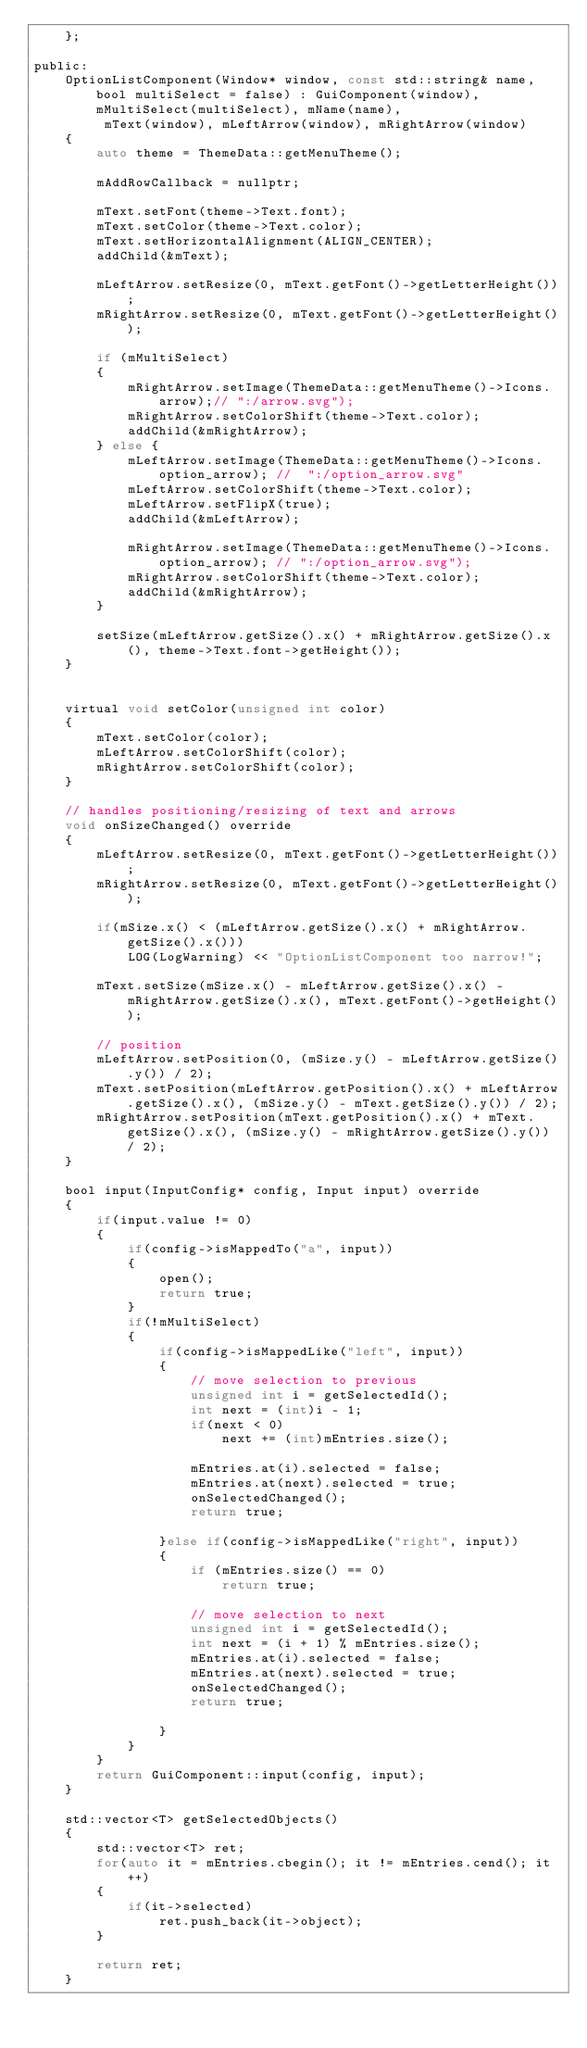Convert code to text. <code><loc_0><loc_0><loc_500><loc_500><_C_>	};

public:
	OptionListComponent(Window* window, const std::string& name, bool multiSelect = false) : GuiComponent(window), mMultiSelect(multiSelect), mName(name),
		 mText(window), mLeftArrow(window), mRightArrow(window)
	{
		auto theme = ThemeData::getMenuTheme();
		
		mAddRowCallback = nullptr;

		mText.setFont(theme->Text.font);
		mText.setColor(theme->Text.color);
		mText.setHorizontalAlignment(ALIGN_CENTER);
		addChild(&mText);

		mLeftArrow.setResize(0, mText.getFont()->getLetterHeight());
		mRightArrow.setResize(0, mText.getFont()->getLetterHeight());

		if (mMultiSelect)
		{
			mRightArrow.setImage(ThemeData::getMenuTheme()->Icons.arrow);// ":/arrow.svg");
			mRightArrow.setColorShift(theme->Text.color);
			addChild(&mRightArrow);
		} else {
			mLeftArrow.setImage(ThemeData::getMenuTheme()->Icons.option_arrow); //  ":/option_arrow.svg"
			mLeftArrow.setColorShift(theme->Text.color);
			mLeftArrow.setFlipX(true);
			addChild(&mLeftArrow);

			mRightArrow.setImage(ThemeData::getMenuTheme()->Icons.option_arrow); // ":/option_arrow.svg");
			mRightArrow.setColorShift(theme->Text.color);
			addChild(&mRightArrow);
		}

		setSize(mLeftArrow.getSize().x() + mRightArrow.getSize().x(), theme->Text.font->getHeight());
	}


	virtual void setColor(unsigned int color)
	{
		mText.setColor(color);
		mLeftArrow.setColorShift(color);
		mRightArrow.setColorShift(color);		
	}

	// handles positioning/resizing of text and arrows
	void onSizeChanged() override
	{
		mLeftArrow.setResize(0, mText.getFont()->getLetterHeight());
		mRightArrow.setResize(0, mText.getFont()->getLetterHeight());

		if(mSize.x() < (mLeftArrow.getSize().x() + mRightArrow.getSize().x()))
			LOG(LogWarning) << "OptionListComponent too narrow!";

		mText.setSize(mSize.x() - mLeftArrow.getSize().x() - mRightArrow.getSize().x(), mText.getFont()->getHeight());

		// position
		mLeftArrow.setPosition(0, (mSize.y() - mLeftArrow.getSize().y()) / 2);
		mText.setPosition(mLeftArrow.getPosition().x() + mLeftArrow.getSize().x(), (mSize.y() - mText.getSize().y()) / 2);
		mRightArrow.setPosition(mText.getPosition().x() + mText.getSize().x(), (mSize.y() - mRightArrow.getSize().y()) / 2);
	}

	bool input(InputConfig* config, Input input) override
	{
		if(input.value != 0)
		{
			if(config->isMappedTo("a", input))
			{
				open();
				return true;
			}
			if(!mMultiSelect)
			{
				if(config->isMappedLike("left", input))
				{
					// move selection to previous
					unsigned int i = getSelectedId();
					int next = (int)i - 1;
					if(next < 0)
						next += (int)mEntries.size();

					mEntries.at(i).selected = false;
					mEntries.at(next).selected = true;
					onSelectedChanged();
					return true;

				}else if(config->isMappedLike("right", input))
				{
					if (mEntries.size() == 0)
						return true;

					// move selection to next
					unsigned int i = getSelectedId();
					int next = (i + 1) % mEntries.size();
					mEntries.at(i).selected = false;
					mEntries.at(next).selected = true;
					onSelectedChanged();
					return true;

				}
			}
		}
		return GuiComponent::input(config, input);
	}

	std::vector<T> getSelectedObjects()
	{
		std::vector<T> ret;
		for(auto it = mEntries.cbegin(); it != mEntries.cend(); it++)
		{
			if(it->selected)
				ret.push_back(it->object);
		}

		return ret;
	}
</code> 